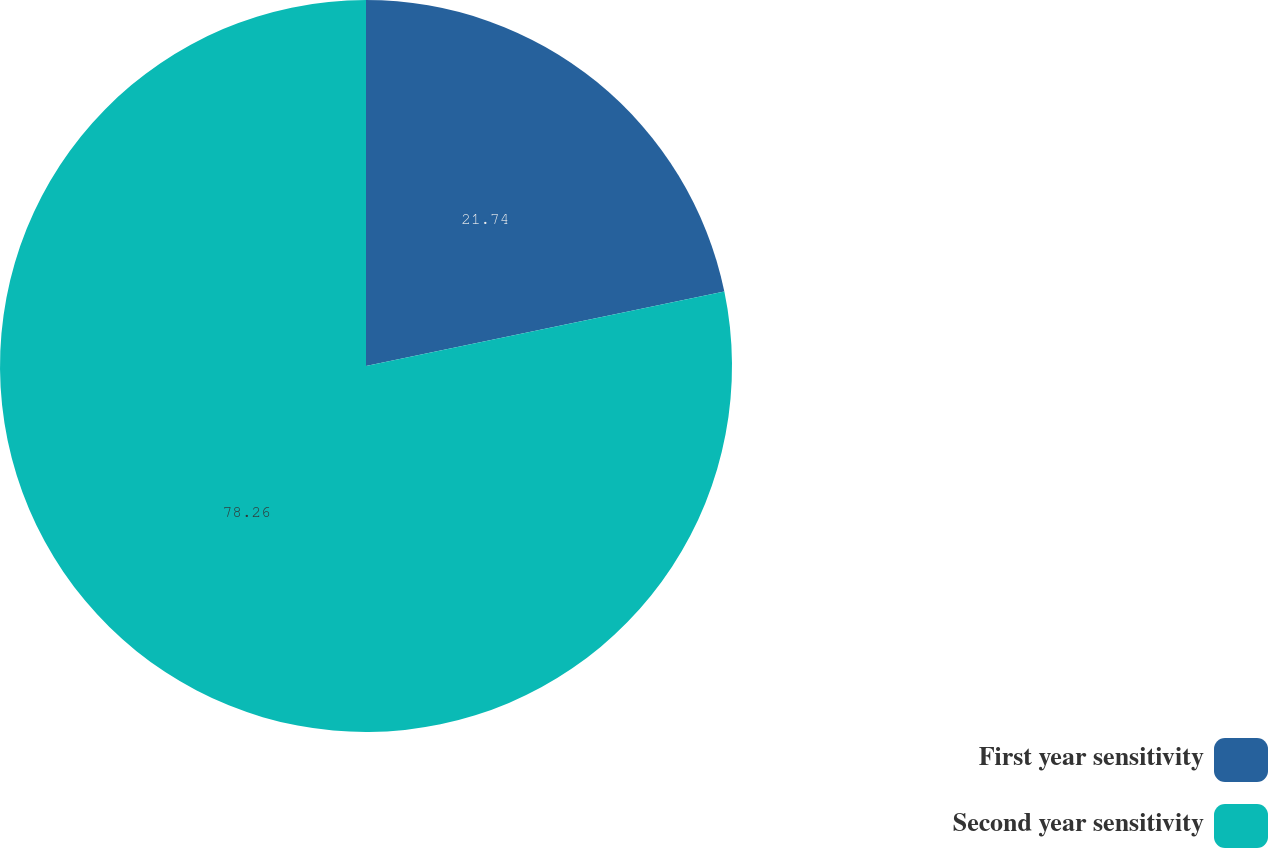Convert chart. <chart><loc_0><loc_0><loc_500><loc_500><pie_chart><fcel>First year sensitivity<fcel>Second year sensitivity<nl><fcel>21.74%<fcel>78.26%<nl></chart> 